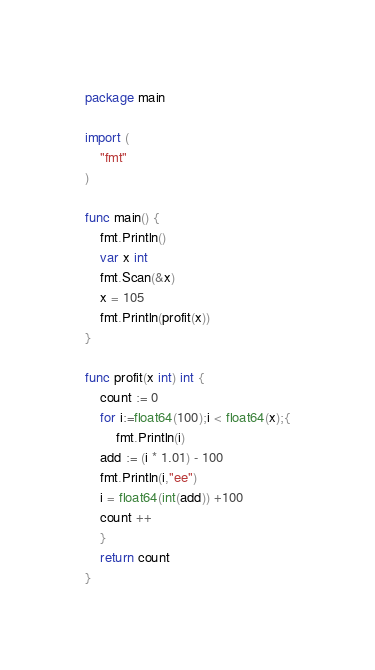<code> <loc_0><loc_0><loc_500><loc_500><_Go_>package main

import (
	"fmt"
)

func main() {
	fmt.Println()
	var x int
	fmt.Scan(&x)
	x = 105
	fmt.Println(profit(x))
}

func profit(x int) int {
	count := 0
	for i:=float64(100);i < float64(x);{
		fmt.Println(i)
	add := (i * 1.01) - 100
	fmt.Println(i,"ee")
	i = float64(int(add)) +100
	count ++
	}
	return count
}
</code> 